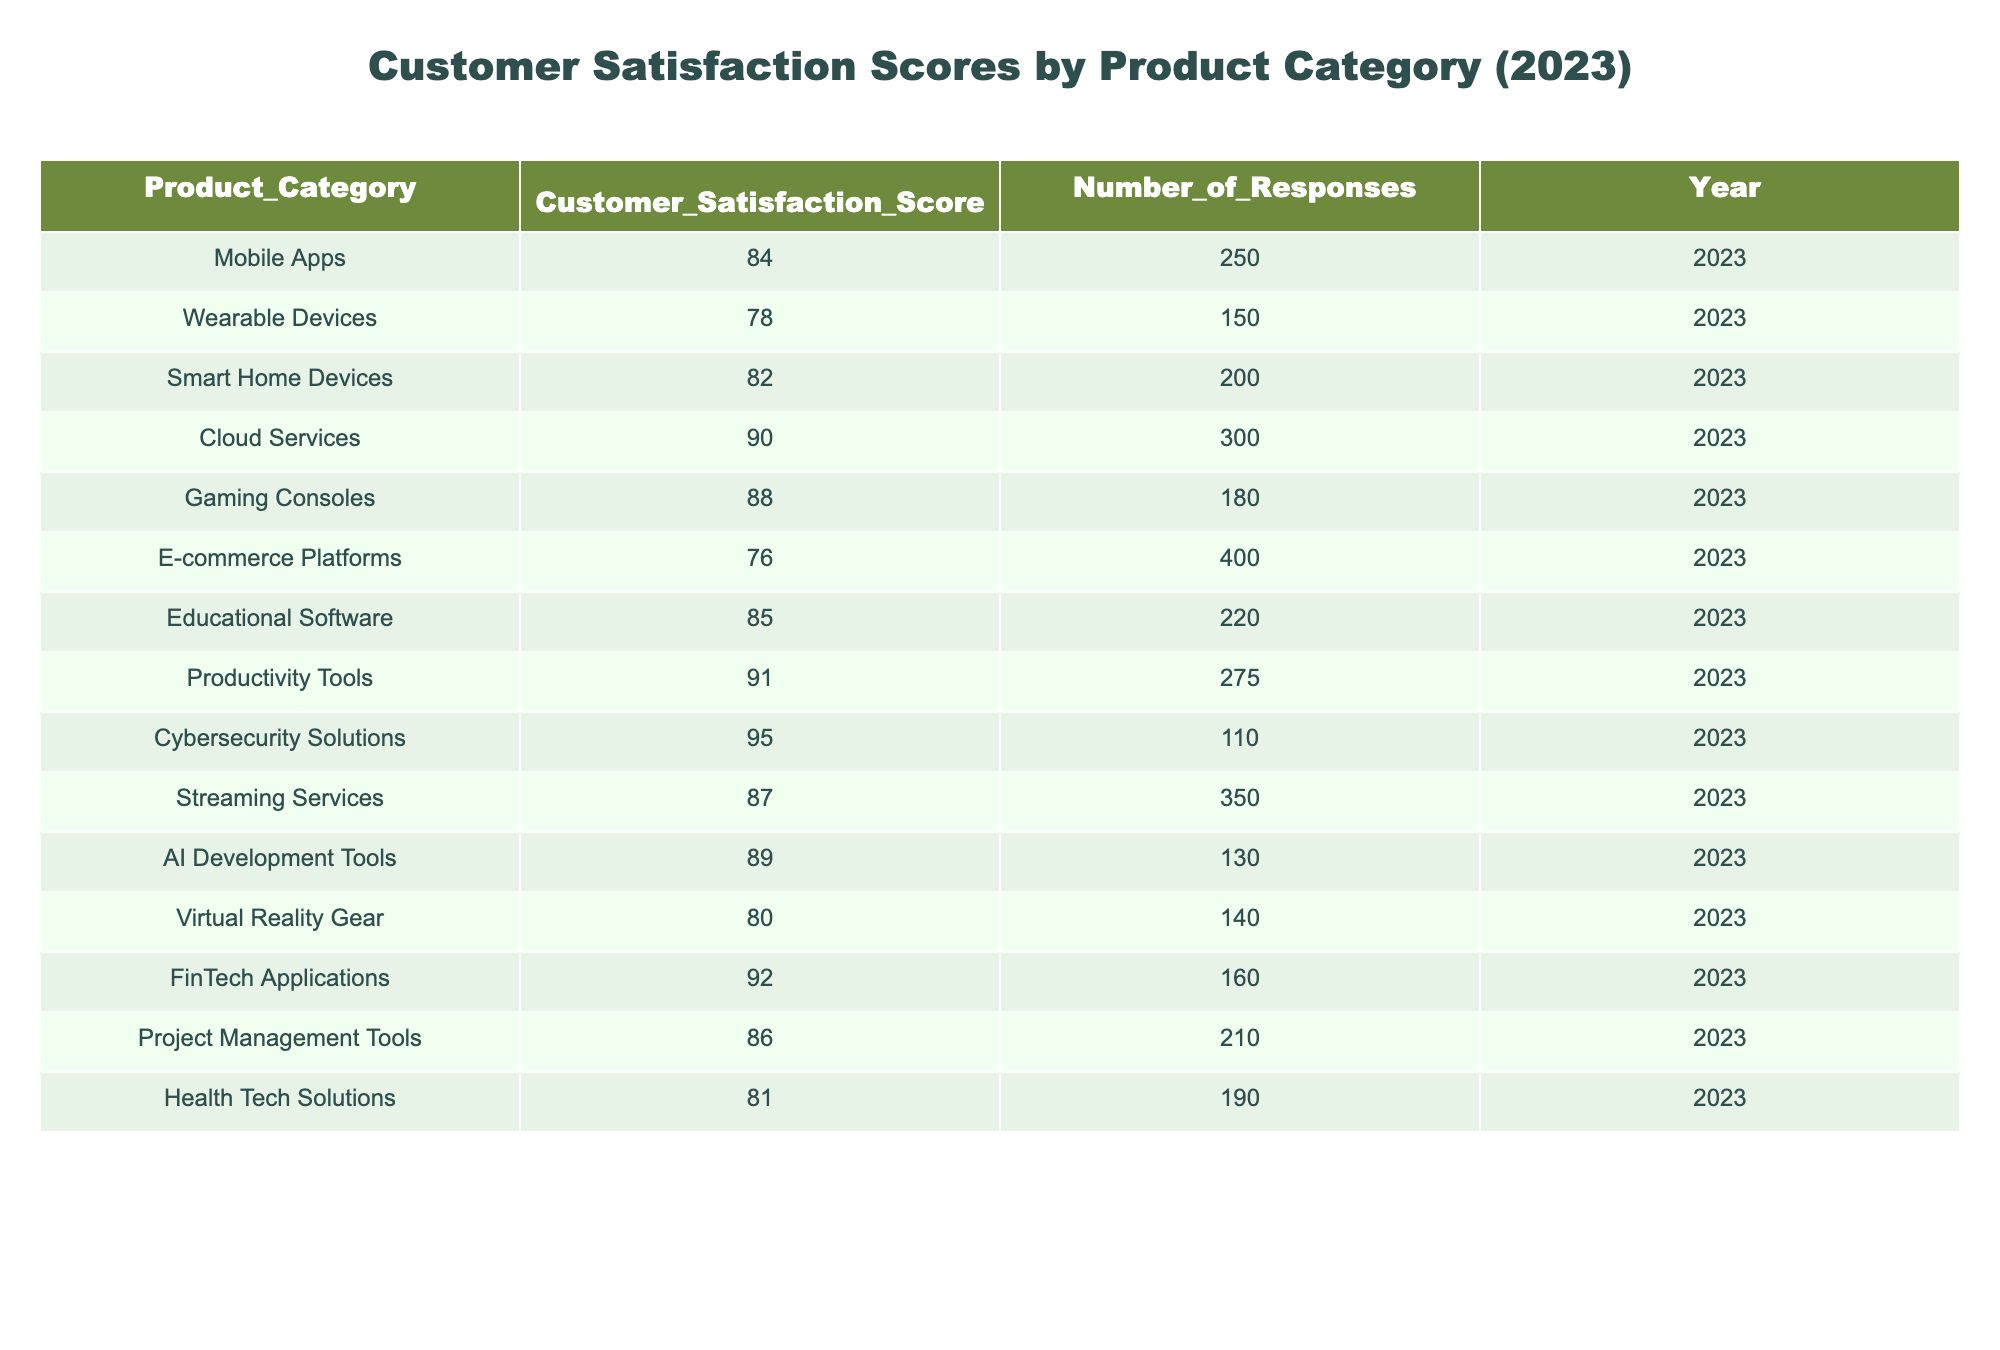What is the customer satisfaction score for Cloud Services? The table indicates that the customer satisfaction score for Cloud Services is listed directly under the Customer Satisfaction Score column corresponding to Cloud Services in the Product_Category column. The score is 90.
Answer: 90 Which product category received the highest customer satisfaction score? By examining all the scores in the table, Cybersecurity Solutions has the highest score at 95, which can be found by comparing all the values in the Customer Satisfaction Score column.
Answer: Cybersecurity Solutions What is the average customer satisfaction score for the Wearable Devices and Virtual Reality Gear categories? To find the average, first locate the scores for Wearable Devices and Virtual Reality Gear, which are 78 and 80, respectively. Then, sum these scores (78 + 80 = 158) and divide by the number of categories (2), yielding an average score of 79.
Answer: 79 Is the customer satisfaction score for E-commerce Platforms above 75? The table shows that the customer satisfaction score for E-commerce Platforms is 76, which is greater than 75. Therefore, the statement is true.
Answer: Yes What is the difference between the customer satisfaction scores of Productivity Tools and Health Tech Solutions? The scores for Productivity Tools and Health Tech Solutions are found to be 91 and 81, respectively. To find the difference, subtract Health Tech Solutions score from Productivity Tools score (91 - 81 = 10). Thus, the difference is 10.
Answer: 10 Which product categories have scores above 85? By reviewing the Customer Satisfaction Score column, the scores that exceed 85 are found in Cloud Services (90), Productivity Tools (91), and Cybersecurity Solutions (95). The process involves listing all the categories and filtering out those with scores below or equal to 85.
Answer: Cloud Services, Productivity Tools, Cybersecurity Solutions What is the total number of responses for all product categories that scored above 85? First, identify the scores above 85, which are 90, 91, 92, 95. Next, sum the Number_of_Responses for these categories: Cloud Services (300), Productivity Tools (275), FinTech Applications (160), and Cybersecurity Solutions (110). Sum these values: 300 + 275 + 160 + 110 = 845.
Answer: 845 Did any product categories receive a customer satisfaction score below 80? By analyzing the scores, we find that both Wearable Devices (78) and E-commerce Platforms (76) have scores lower than 80. Therefore, the answer to whether any product category received below this threshold is yes.
Answer: Yes What category had the second lowest customer satisfaction score, and what was that score? The lowest score is from E-commerce Platforms (76), and the second lowest is from Wearable Devices (78). To identify them, we can sort the scores and find the lowest two, yielding the second lowest as 78.
Answer: Wearable Devices, 78 